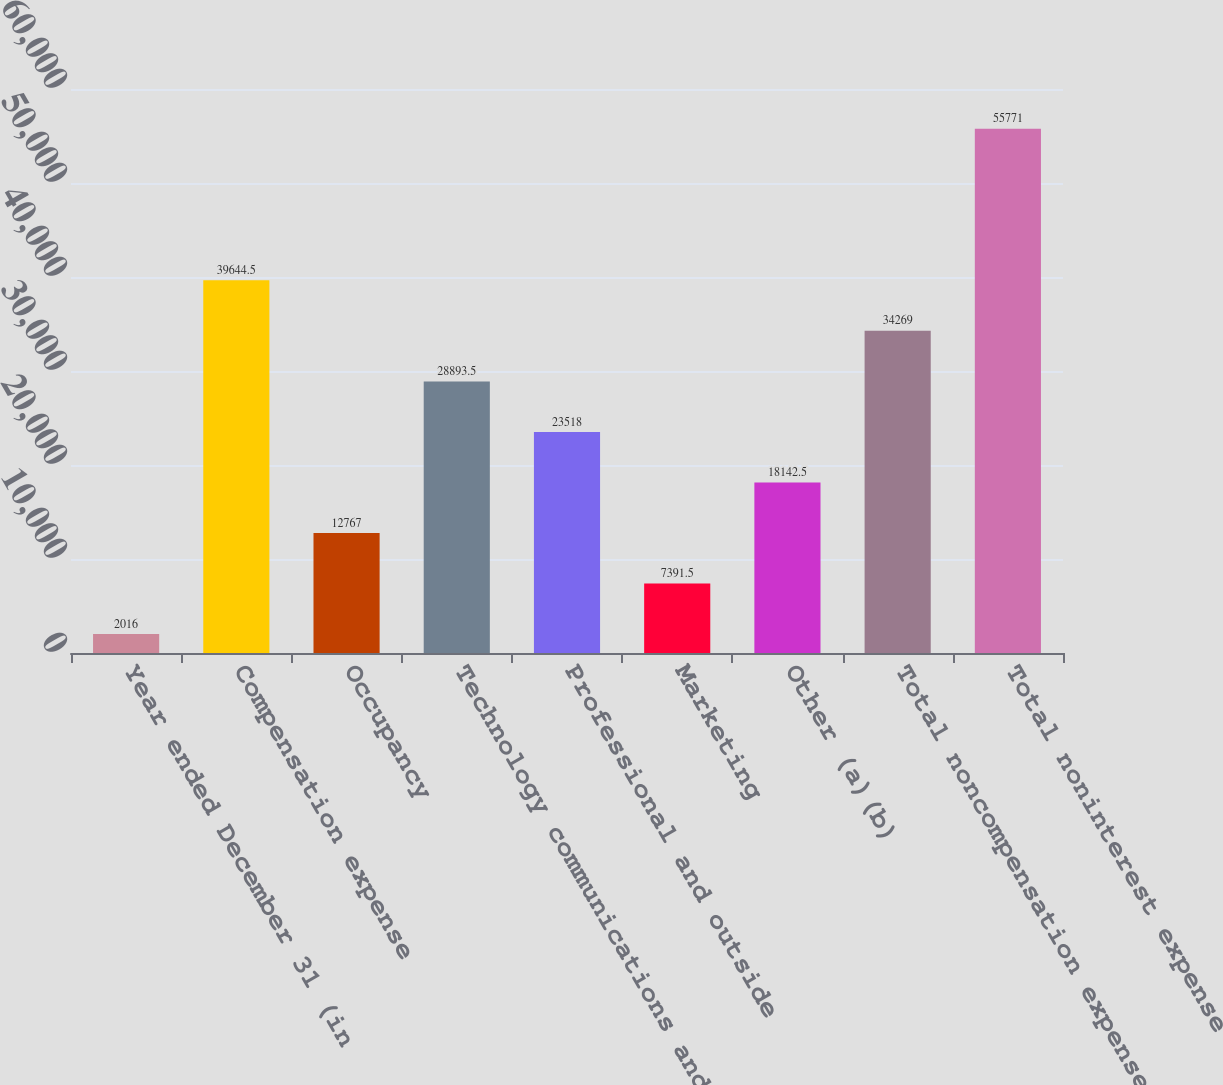<chart> <loc_0><loc_0><loc_500><loc_500><bar_chart><fcel>Year ended December 31 (in<fcel>Compensation expense<fcel>Occupancy<fcel>Technology communications and<fcel>Professional and outside<fcel>Marketing<fcel>Other (a)(b)<fcel>Total noncompensation expense<fcel>Total noninterest expense<nl><fcel>2016<fcel>39644.5<fcel>12767<fcel>28893.5<fcel>23518<fcel>7391.5<fcel>18142.5<fcel>34269<fcel>55771<nl></chart> 